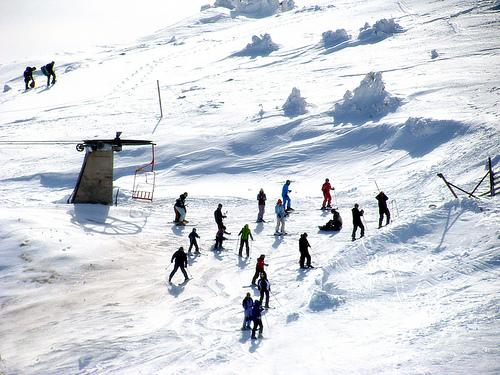What color is the ski lift chair, and what is a notable feature of it? The ski lift chair is red, and one notable feature is that it appears broken. Mention the color combinations people wear in their skiing outfits. Red, blue and black, blue, and green are some color combinations people wear in their skiing outfits. Detail the significant elements in the image related to the ski lift. There is a red ski lift chair, black metal ski lift cable, broken ski lift, grey concrete and metal ski lift endpoint, and the concrete base of the ski lift. State the count of skier(s) wearing a green outfit and skier(s) wearing a red outfit. There is 1 skier wearing a green outfit and 1 skier wearing a red outfit. Can you identify the person lying on the snow and describe their winter attire? The person sitting on the snow is wearing a green jacket. Briefly describe any peculiar scenario or unusual incidents that are happening in the picture. There is a person standing with inverted legs, and there seems to be a broken ski lift. Comment on the quality of the image, taking into account the objects' visibility and clarity. The image quality seems to be decent, with objects being able to be identified and described, but there might be some lack of clarity on certain objects. Examine the techniques and tactics used by skiers as observed in the picture. One skier is taking a break, and another skier is using technique to control speed. Explain the landscape and some notable geological features seen in the image. The landscape is snowy with white snow covering the ground, snow bergs forming and large white snow piles. Enumerate the distinct sentiments the image may convey. Feelings of fun, excitement, adventure, cold, and possible concern over the broken ski lift. 